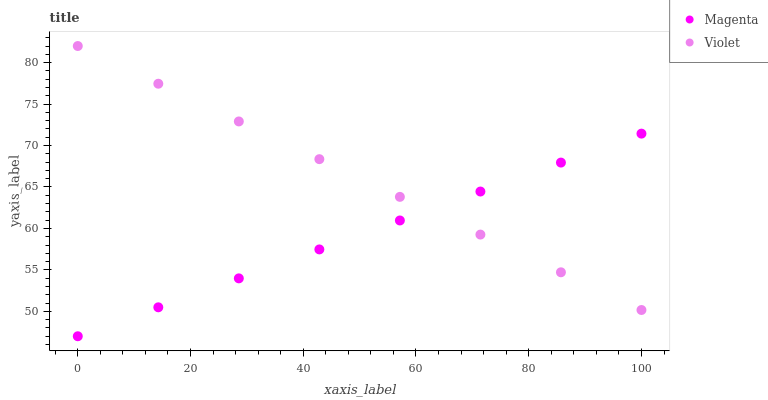Does Magenta have the minimum area under the curve?
Answer yes or no. Yes. Does Violet have the maximum area under the curve?
Answer yes or no. Yes. Does Violet have the minimum area under the curve?
Answer yes or no. No. Is Magenta the smoothest?
Answer yes or no. Yes. Is Violet the roughest?
Answer yes or no. Yes. Is Violet the smoothest?
Answer yes or no. No. Does Magenta have the lowest value?
Answer yes or no. Yes. Does Violet have the lowest value?
Answer yes or no. No. Does Violet have the highest value?
Answer yes or no. Yes. Does Magenta intersect Violet?
Answer yes or no. Yes. Is Magenta less than Violet?
Answer yes or no. No. Is Magenta greater than Violet?
Answer yes or no. No. 